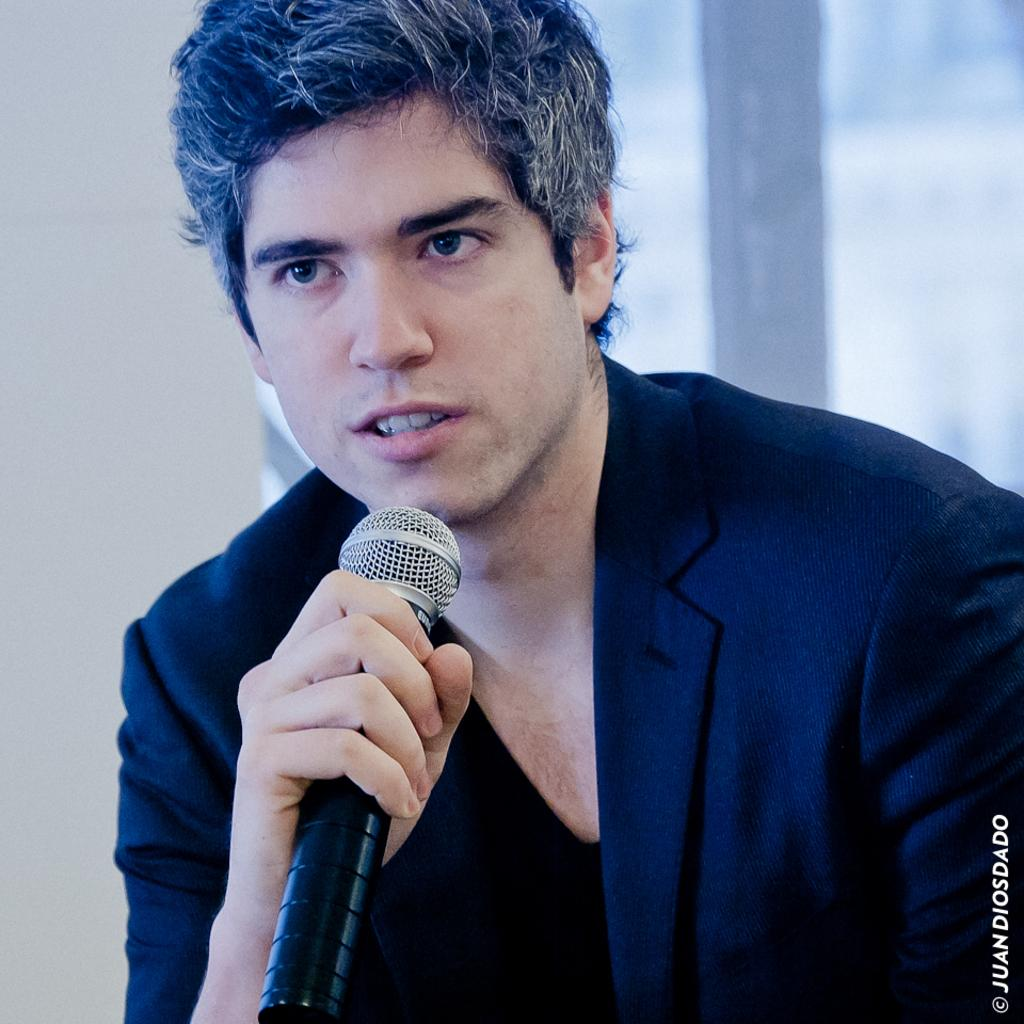What is the main subject of the image? There is a person in the image. What is the person holding in the image? The person is holding a mic. What type of brick is being used to process the information in the image? There is no brick or information processing visible in the image; it features a person holding a mic. 